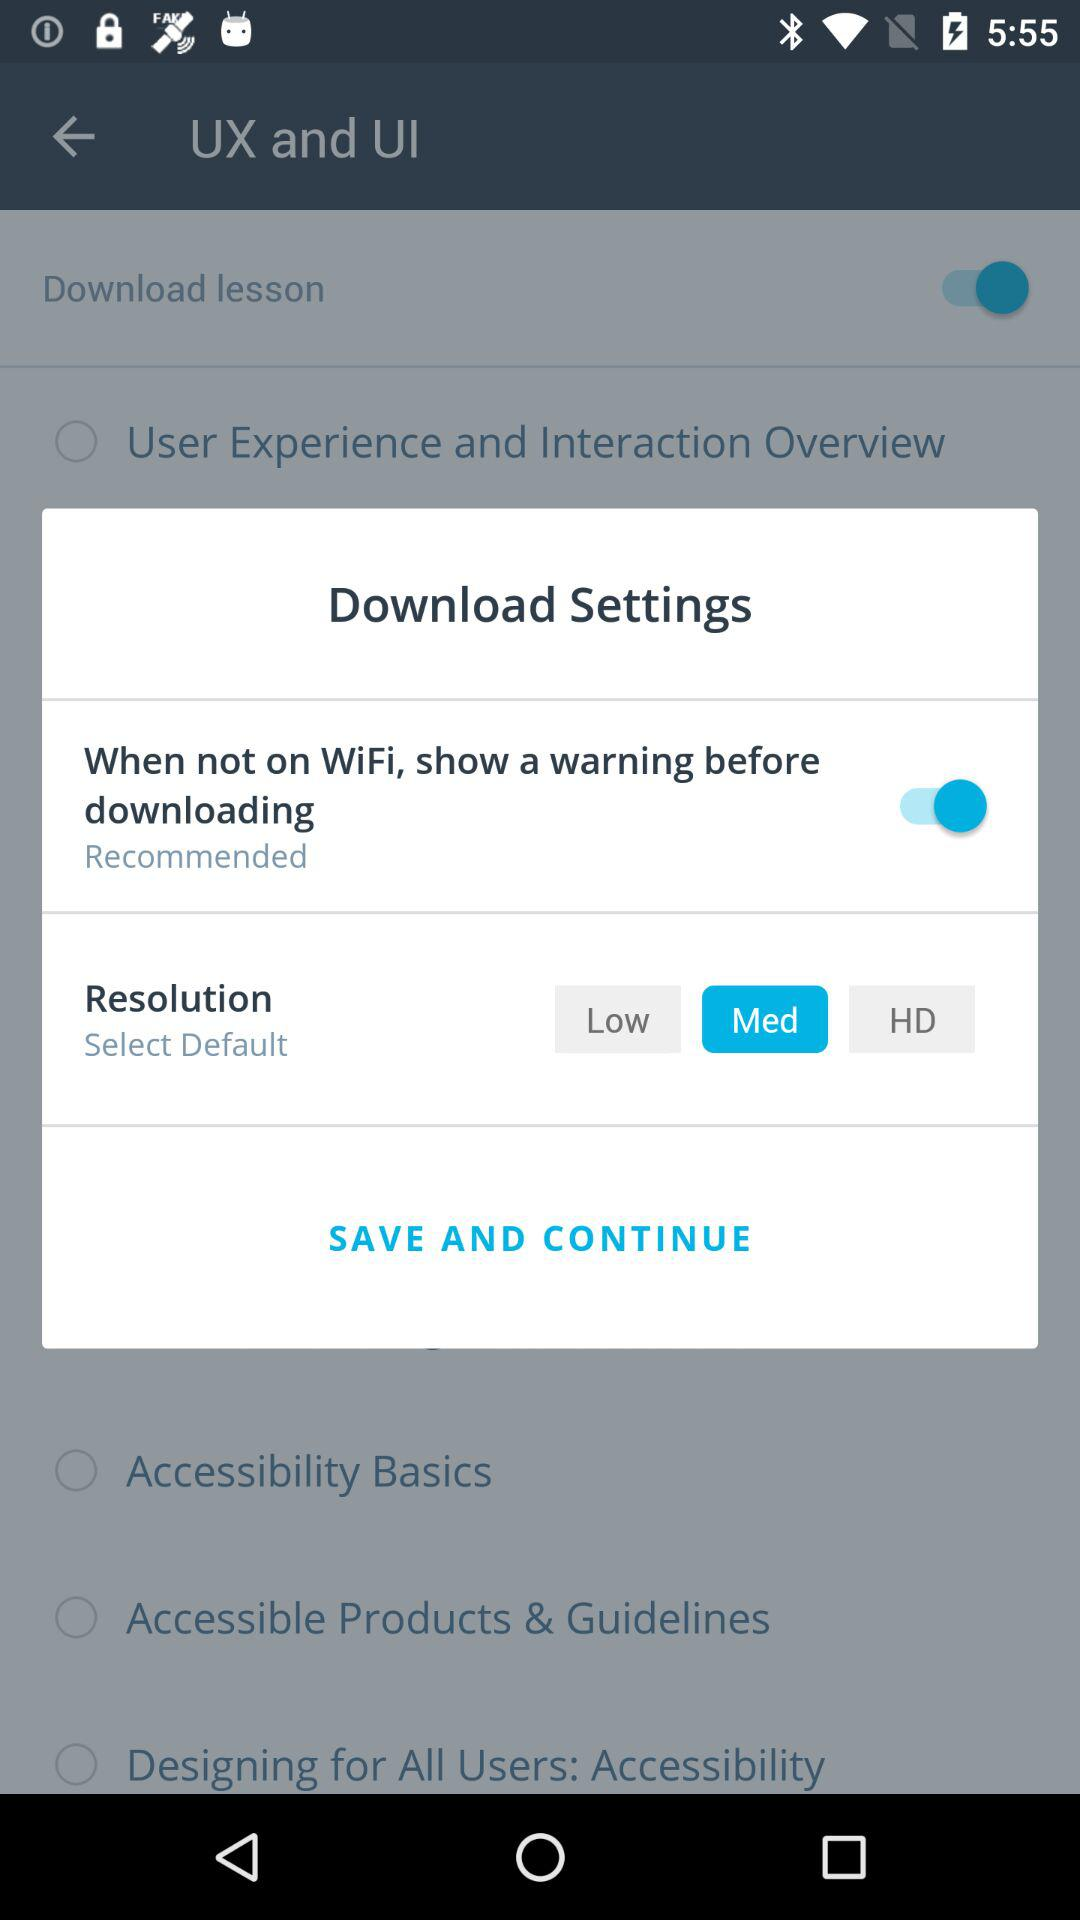What is the current status of the "When not on WiFi, show a warning before downloading" setting? The current status is "on". 